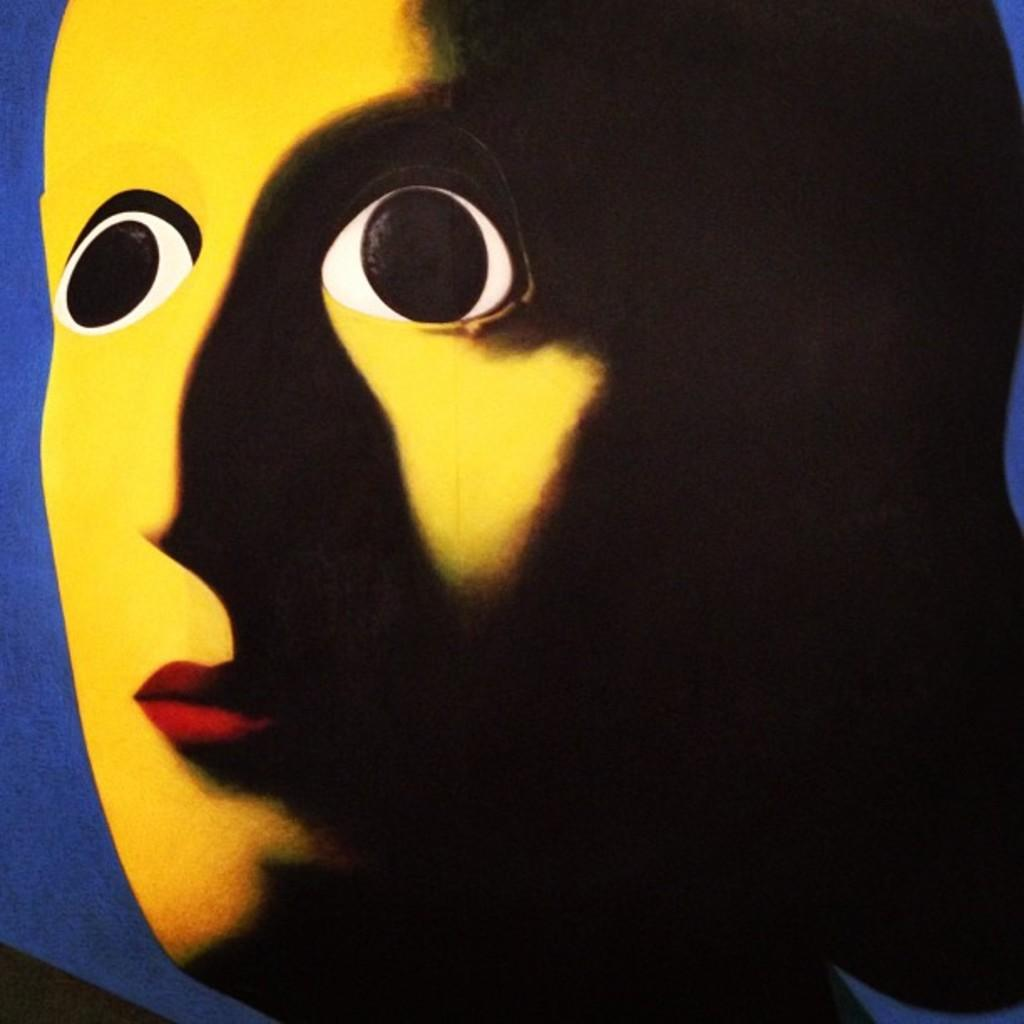What color is the mask in the image? The mask in the image is yellow. Can you describe any additional features of the mask? There is a black shadow on the right side of the mask. How many frogs are sitting on the lip of the mask in the image? There are no frogs present in the image, and the mask does not have a lip. 